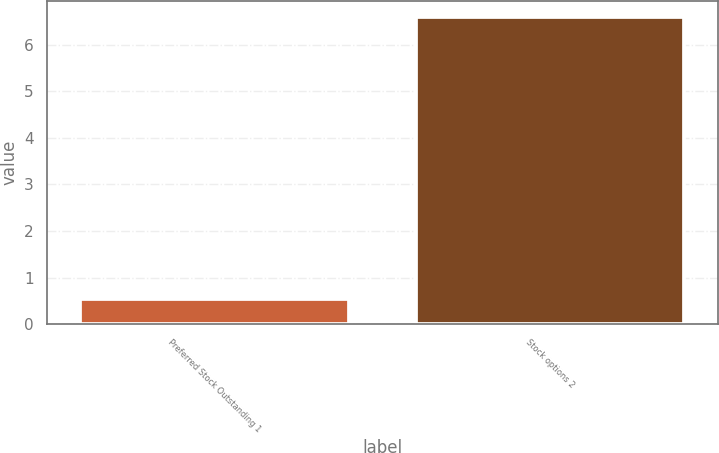<chart> <loc_0><loc_0><loc_500><loc_500><bar_chart><fcel>Preferred Stock Outstanding 1<fcel>Stock options 2<nl><fcel>0.54<fcel>6.6<nl></chart> 